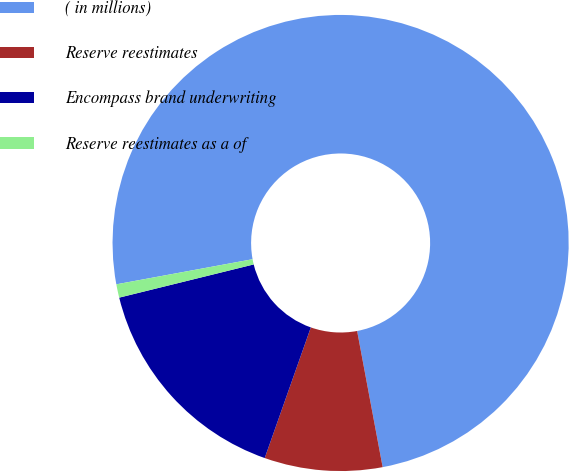Convert chart to OTSL. <chart><loc_0><loc_0><loc_500><loc_500><pie_chart><fcel>( in millions)<fcel>Reserve reestimates<fcel>Encompass brand underwriting<fcel>Reserve reestimates as a of<nl><fcel>74.95%<fcel>8.35%<fcel>15.75%<fcel>0.95%<nl></chart> 